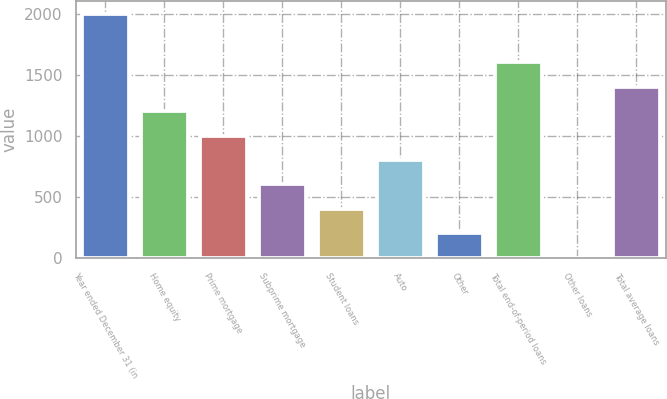Convert chart to OTSL. <chart><loc_0><loc_0><loc_500><loc_500><bar_chart><fcel>Year ended December 31 (in<fcel>Home equity<fcel>Prime mortgage<fcel>Subprime mortgage<fcel>Student loans<fcel>Auto<fcel>Other<fcel>Total end-of-period loans<fcel>Other loans<fcel>Total average loans<nl><fcel>2006<fcel>1204.56<fcel>1004.2<fcel>603.48<fcel>403.12<fcel>803.84<fcel>202.76<fcel>1605.28<fcel>2.4<fcel>1404.92<nl></chart> 